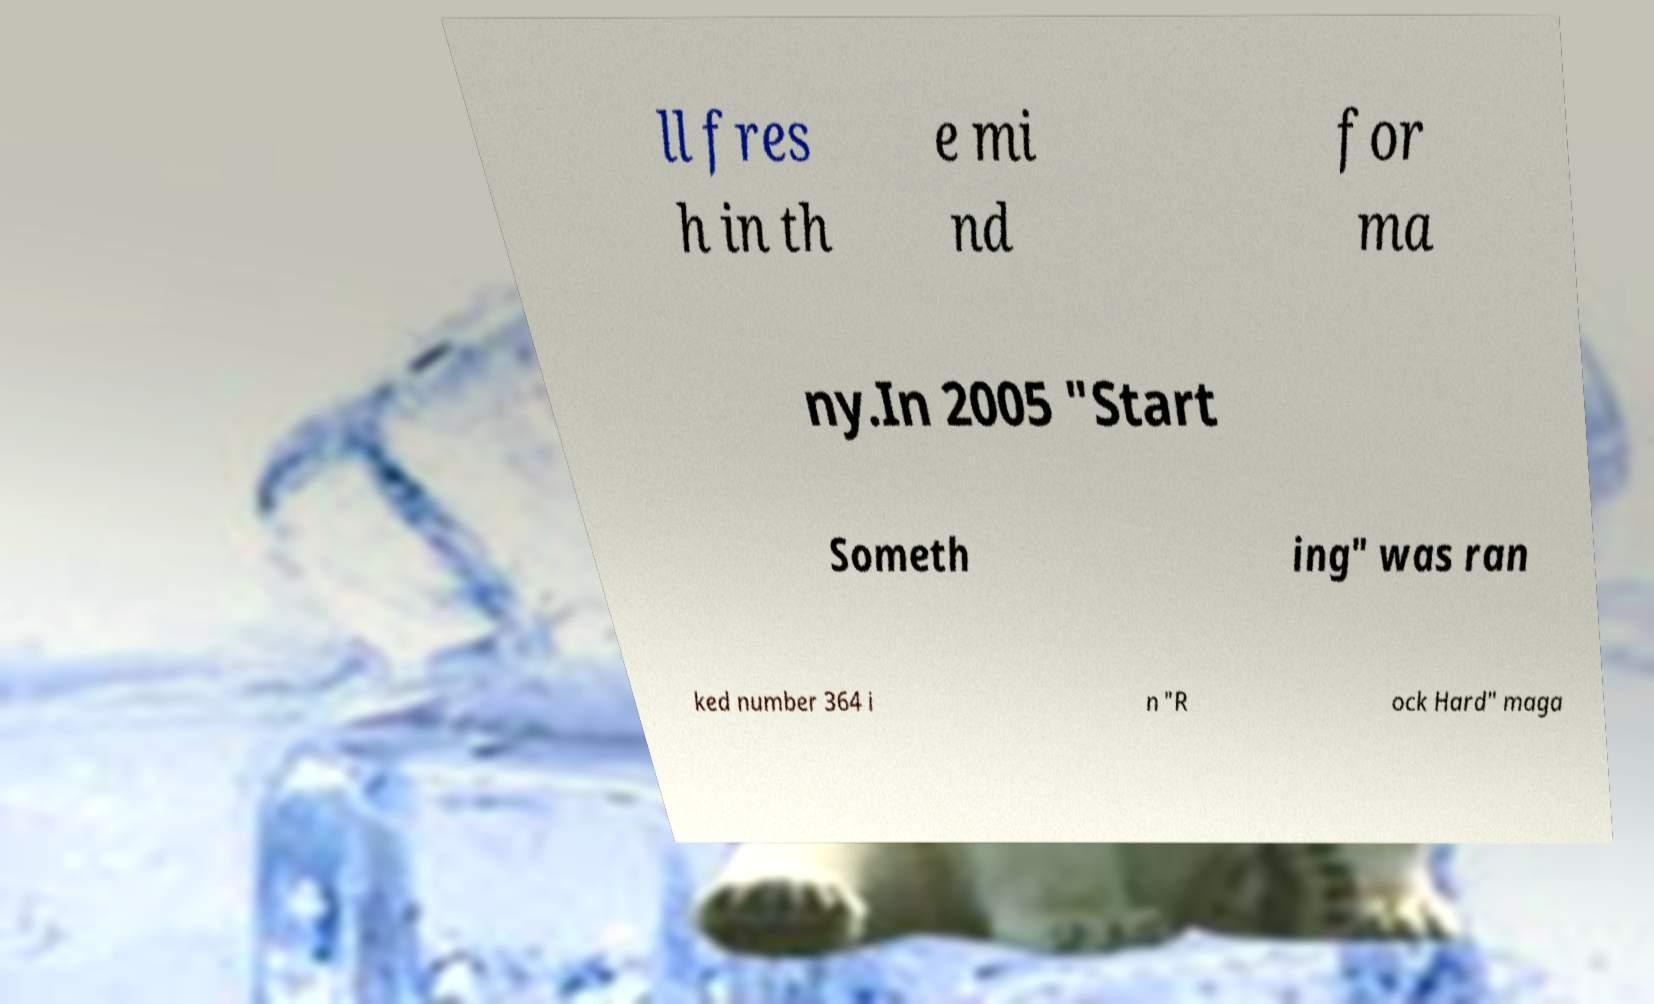Could you extract and type out the text from this image? ll fres h in th e mi nd for ma ny.In 2005 "Start Someth ing" was ran ked number 364 i n "R ock Hard" maga 